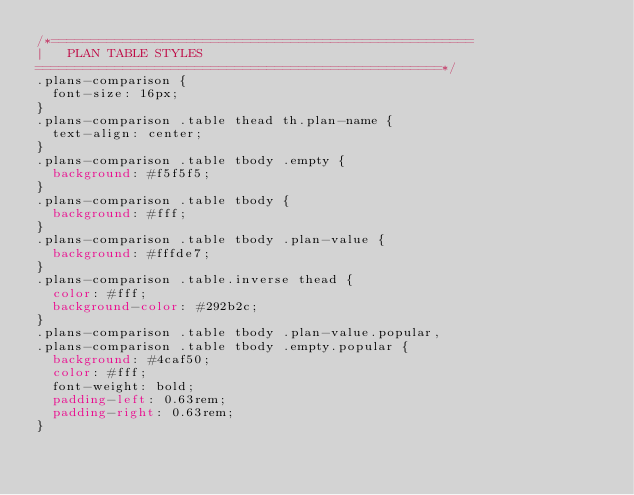<code> <loc_0><loc_0><loc_500><loc_500><_CSS_>/*=====================================================
|   PLAN TABLE STYLES
===================================================*/
.plans-comparison {
  font-size: 16px;
}
.plans-comparison .table thead th.plan-name {
  text-align: center;
}
.plans-comparison .table tbody .empty {
  background: #f5f5f5;
}
.plans-comparison .table tbody {
  background: #fff;
}
.plans-comparison .table tbody .plan-value {
  background: #fffde7;
}
.plans-comparison .table.inverse thead {
  color: #fff;
  background-color: #292b2c;
}
.plans-comparison .table tbody .plan-value.popular,
.plans-comparison .table tbody .empty.popular {
  background: #4caf50;
  color: #fff;
  font-weight: bold;
  padding-left: 0.63rem;
  padding-right: 0.63rem;
}</code> 